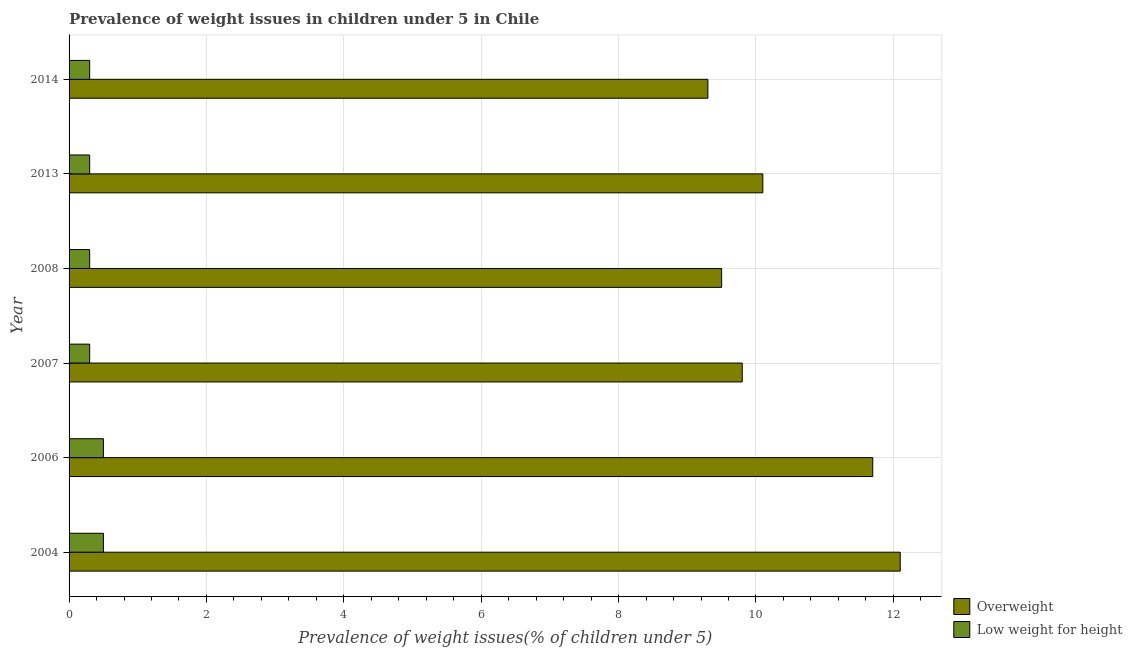Are the number of bars per tick equal to the number of legend labels?
Ensure brevity in your answer.  Yes. How many bars are there on the 5th tick from the top?
Provide a succinct answer. 2. What is the label of the 6th group of bars from the top?
Provide a succinct answer. 2004. What is the percentage of overweight children in 2004?
Your answer should be compact. 12.1. Across all years, what is the minimum percentage of overweight children?
Offer a terse response. 9.3. In which year was the percentage of underweight children maximum?
Your answer should be very brief. 2004. In which year was the percentage of overweight children minimum?
Provide a succinct answer. 2014. What is the total percentage of underweight children in the graph?
Provide a succinct answer. 2.2. What is the difference between the percentage of underweight children in 2004 and that in 2006?
Your answer should be very brief. 0. What is the difference between the percentage of overweight children in 2008 and the percentage of underweight children in 2013?
Give a very brief answer. 9.2. What is the average percentage of overweight children per year?
Your answer should be compact. 10.42. In how many years, is the percentage of overweight children greater than 10.4 %?
Offer a terse response. 2. What is the ratio of the percentage of underweight children in 2006 to that in 2014?
Ensure brevity in your answer.  1.67. Is the difference between the percentage of overweight children in 2008 and 2013 greater than the difference between the percentage of underweight children in 2008 and 2013?
Provide a succinct answer. No. What is the difference between the highest and the second highest percentage of overweight children?
Your response must be concise. 0.4. What is the difference between the highest and the lowest percentage of underweight children?
Your answer should be compact. 0.2. What does the 2nd bar from the top in 2004 represents?
Offer a very short reply. Overweight. What does the 1st bar from the bottom in 2007 represents?
Offer a very short reply. Overweight. Are all the bars in the graph horizontal?
Provide a short and direct response. Yes. How many years are there in the graph?
Your response must be concise. 6. Does the graph contain grids?
Your answer should be very brief. Yes. What is the title of the graph?
Your response must be concise. Prevalence of weight issues in children under 5 in Chile. What is the label or title of the X-axis?
Ensure brevity in your answer.  Prevalence of weight issues(% of children under 5). What is the label or title of the Y-axis?
Your response must be concise. Year. What is the Prevalence of weight issues(% of children under 5) in Overweight in 2004?
Your response must be concise. 12.1. What is the Prevalence of weight issues(% of children under 5) of Overweight in 2006?
Your answer should be very brief. 11.7. What is the Prevalence of weight issues(% of children under 5) of Low weight for height in 2006?
Make the answer very short. 0.5. What is the Prevalence of weight issues(% of children under 5) in Overweight in 2007?
Ensure brevity in your answer.  9.8. What is the Prevalence of weight issues(% of children under 5) of Low weight for height in 2007?
Keep it short and to the point. 0.3. What is the Prevalence of weight issues(% of children under 5) of Low weight for height in 2008?
Make the answer very short. 0.3. What is the Prevalence of weight issues(% of children under 5) in Overweight in 2013?
Your answer should be very brief. 10.1. What is the Prevalence of weight issues(% of children under 5) in Low weight for height in 2013?
Make the answer very short. 0.3. What is the Prevalence of weight issues(% of children under 5) of Overweight in 2014?
Your response must be concise. 9.3. What is the Prevalence of weight issues(% of children under 5) of Low weight for height in 2014?
Provide a succinct answer. 0.3. Across all years, what is the maximum Prevalence of weight issues(% of children under 5) in Overweight?
Offer a very short reply. 12.1. Across all years, what is the maximum Prevalence of weight issues(% of children under 5) in Low weight for height?
Make the answer very short. 0.5. Across all years, what is the minimum Prevalence of weight issues(% of children under 5) in Overweight?
Provide a short and direct response. 9.3. Across all years, what is the minimum Prevalence of weight issues(% of children under 5) of Low weight for height?
Your response must be concise. 0.3. What is the total Prevalence of weight issues(% of children under 5) in Overweight in the graph?
Your response must be concise. 62.5. What is the difference between the Prevalence of weight issues(% of children under 5) in Overweight in 2004 and that in 2006?
Your response must be concise. 0.4. What is the difference between the Prevalence of weight issues(% of children under 5) of Low weight for height in 2004 and that in 2006?
Offer a terse response. 0. What is the difference between the Prevalence of weight issues(% of children under 5) of Overweight in 2004 and that in 2008?
Your answer should be very brief. 2.6. What is the difference between the Prevalence of weight issues(% of children under 5) of Low weight for height in 2004 and that in 2008?
Make the answer very short. 0.2. What is the difference between the Prevalence of weight issues(% of children under 5) in Low weight for height in 2004 and that in 2013?
Provide a short and direct response. 0.2. What is the difference between the Prevalence of weight issues(% of children under 5) in Overweight in 2004 and that in 2014?
Offer a terse response. 2.8. What is the difference between the Prevalence of weight issues(% of children under 5) in Low weight for height in 2006 and that in 2008?
Ensure brevity in your answer.  0.2. What is the difference between the Prevalence of weight issues(% of children under 5) in Overweight in 2006 and that in 2013?
Ensure brevity in your answer.  1.6. What is the difference between the Prevalence of weight issues(% of children under 5) in Low weight for height in 2006 and that in 2013?
Offer a terse response. 0.2. What is the difference between the Prevalence of weight issues(% of children under 5) of Overweight in 2006 and that in 2014?
Give a very brief answer. 2.4. What is the difference between the Prevalence of weight issues(% of children under 5) in Overweight in 2007 and that in 2013?
Keep it short and to the point. -0.3. What is the difference between the Prevalence of weight issues(% of children under 5) in Low weight for height in 2007 and that in 2013?
Provide a short and direct response. 0. What is the difference between the Prevalence of weight issues(% of children under 5) of Overweight in 2008 and that in 2013?
Your answer should be compact. -0.6. What is the difference between the Prevalence of weight issues(% of children under 5) in Overweight in 2008 and that in 2014?
Your answer should be very brief. 0.2. What is the difference between the Prevalence of weight issues(% of children under 5) in Overweight in 2004 and the Prevalence of weight issues(% of children under 5) in Low weight for height in 2007?
Ensure brevity in your answer.  11.8. What is the difference between the Prevalence of weight issues(% of children under 5) of Overweight in 2004 and the Prevalence of weight issues(% of children under 5) of Low weight for height in 2008?
Your answer should be very brief. 11.8. What is the difference between the Prevalence of weight issues(% of children under 5) of Overweight in 2004 and the Prevalence of weight issues(% of children under 5) of Low weight for height in 2014?
Your answer should be very brief. 11.8. What is the difference between the Prevalence of weight issues(% of children under 5) of Overweight in 2006 and the Prevalence of weight issues(% of children under 5) of Low weight for height in 2008?
Your response must be concise. 11.4. What is the difference between the Prevalence of weight issues(% of children under 5) in Overweight in 2006 and the Prevalence of weight issues(% of children under 5) in Low weight for height in 2013?
Your response must be concise. 11.4. What is the difference between the Prevalence of weight issues(% of children under 5) in Overweight in 2006 and the Prevalence of weight issues(% of children under 5) in Low weight for height in 2014?
Provide a succinct answer. 11.4. What is the difference between the Prevalence of weight issues(% of children under 5) in Overweight in 2007 and the Prevalence of weight issues(% of children under 5) in Low weight for height in 2008?
Offer a terse response. 9.5. What is the difference between the Prevalence of weight issues(% of children under 5) in Overweight in 2008 and the Prevalence of weight issues(% of children under 5) in Low weight for height in 2013?
Your answer should be very brief. 9.2. What is the average Prevalence of weight issues(% of children under 5) in Overweight per year?
Provide a succinct answer. 10.42. What is the average Prevalence of weight issues(% of children under 5) of Low weight for height per year?
Keep it short and to the point. 0.37. In the year 2007, what is the difference between the Prevalence of weight issues(% of children under 5) in Overweight and Prevalence of weight issues(% of children under 5) in Low weight for height?
Your response must be concise. 9.5. In the year 2008, what is the difference between the Prevalence of weight issues(% of children under 5) in Overweight and Prevalence of weight issues(% of children under 5) in Low weight for height?
Your answer should be compact. 9.2. In the year 2014, what is the difference between the Prevalence of weight issues(% of children under 5) in Overweight and Prevalence of weight issues(% of children under 5) in Low weight for height?
Make the answer very short. 9. What is the ratio of the Prevalence of weight issues(% of children under 5) of Overweight in 2004 to that in 2006?
Your answer should be very brief. 1.03. What is the ratio of the Prevalence of weight issues(% of children under 5) in Overweight in 2004 to that in 2007?
Ensure brevity in your answer.  1.23. What is the ratio of the Prevalence of weight issues(% of children under 5) in Overweight in 2004 to that in 2008?
Ensure brevity in your answer.  1.27. What is the ratio of the Prevalence of weight issues(% of children under 5) of Low weight for height in 2004 to that in 2008?
Offer a terse response. 1.67. What is the ratio of the Prevalence of weight issues(% of children under 5) of Overweight in 2004 to that in 2013?
Make the answer very short. 1.2. What is the ratio of the Prevalence of weight issues(% of children under 5) in Overweight in 2004 to that in 2014?
Offer a terse response. 1.3. What is the ratio of the Prevalence of weight issues(% of children under 5) of Overweight in 2006 to that in 2007?
Offer a terse response. 1.19. What is the ratio of the Prevalence of weight issues(% of children under 5) in Low weight for height in 2006 to that in 2007?
Keep it short and to the point. 1.67. What is the ratio of the Prevalence of weight issues(% of children under 5) in Overweight in 2006 to that in 2008?
Offer a very short reply. 1.23. What is the ratio of the Prevalence of weight issues(% of children under 5) in Low weight for height in 2006 to that in 2008?
Your answer should be compact. 1.67. What is the ratio of the Prevalence of weight issues(% of children under 5) of Overweight in 2006 to that in 2013?
Your answer should be very brief. 1.16. What is the ratio of the Prevalence of weight issues(% of children under 5) in Low weight for height in 2006 to that in 2013?
Your response must be concise. 1.67. What is the ratio of the Prevalence of weight issues(% of children under 5) of Overweight in 2006 to that in 2014?
Offer a terse response. 1.26. What is the ratio of the Prevalence of weight issues(% of children under 5) in Low weight for height in 2006 to that in 2014?
Provide a short and direct response. 1.67. What is the ratio of the Prevalence of weight issues(% of children under 5) in Overweight in 2007 to that in 2008?
Your answer should be compact. 1.03. What is the ratio of the Prevalence of weight issues(% of children under 5) of Overweight in 2007 to that in 2013?
Give a very brief answer. 0.97. What is the ratio of the Prevalence of weight issues(% of children under 5) in Low weight for height in 2007 to that in 2013?
Give a very brief answer. 1. What is the ratio of the Prevalence of weight issues(% of children under 5) of Overweight in 2007 to that in 2014?
Provide a succinct answer. 1.05. What is the ratio of the Prevalence of weight issues(% of children under 5) of Low weight for height in 2007 to that in 2014?
Your answer should be very brief. 1. What is the ratio of the Prevalence of weight issues(% of children under 5) of Overweight in 2008 to that in 2013?
Provide a short and direct response. 0.94. What is the ratio of the Prevalence of weight issues(% of children under 5) in Overweight in 2008 to that in 2014?
Provide a short and direct response. 1.02. What is the ratio of the Prevalence of weight issues(% of children under 5) of Low weight for height in 2008 to that in 2014?
Provide a succinct answer. 1. What is the ratio of the Prevalence of weight issues(% of children under 5) in Overweight in 2013 to that in 2014?
Your answer should be very brief. 1.09. What is the ratio of the Prevalence of weight issues(% of children under 5) of Low weight for height in 2013 to that in 2014?
Your response must be concise. 1. 